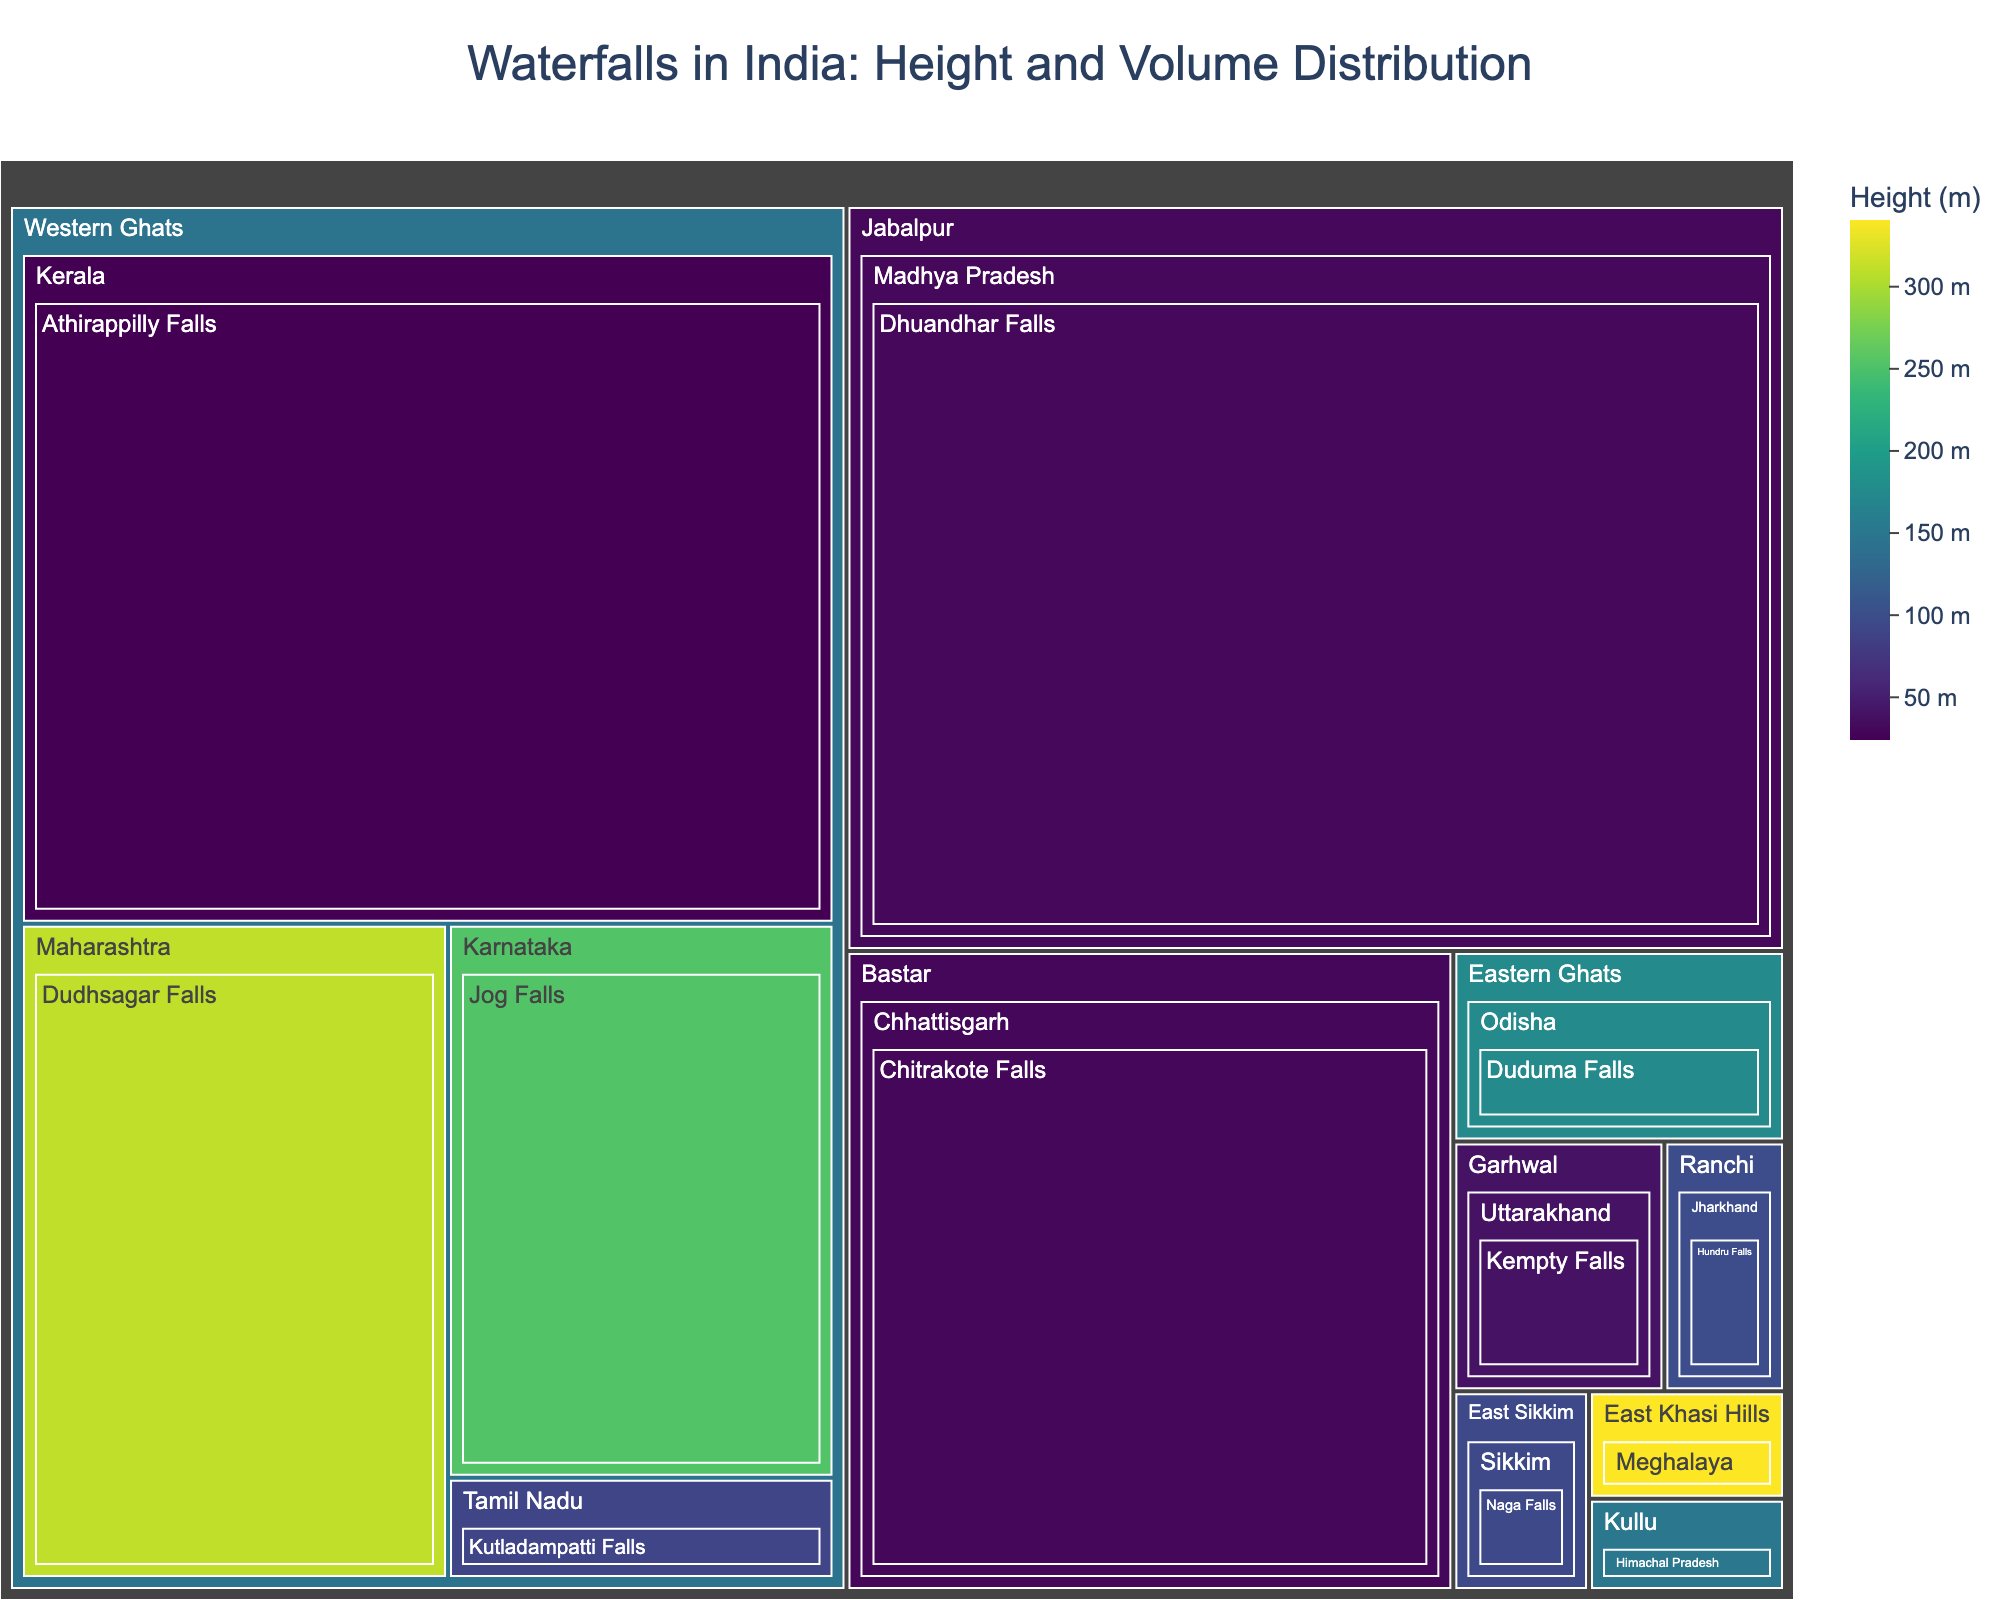What is the height of Nohkalikai Falls? Look for the Nohkalikai Falls in the East Khasi Hills, Meghalaya region in the treemap, and check the height value associated with it.
Answer: 340 meters Which waterfall has the highest water volume? Identify the waterfall with the largest area in the treemap representing volume and verify the numerical value.
Answer: Dhuandhar Falls What is the average height of waterfalls in the Western Ghats region? Identify all waterfalls in the Western Ghats region: Jog Falls, Kutladampatti Falls, Dudhsagar Falls, Athirappilly Falls. Add their heights (253 + 90 + 310 + 24 = 677) and divide by the number of waterfalls (4).
Answer: 169.25 meters Which region contains the highest waterfall? Identify the waterfall with the greatest height in the treemap and note its region.
Answer: East Khasi Hills (Nohkalikai Falls) How many waterfalls are there in the Eastern Ghats region? Locate the Eastern Ghats region on the treemap and count the waterfalls within it.
Answer: 1 Which waterfall in the Western Ghats has the largest water volume? Locate each waterfall in the Western Ghats (Jog Falls, Kutladampatti Falls, Dudhsagar Falls, Athirappilly Falls) and compare their volumes.
Answer: Athirappilly Falls What is the combined water volume of the waterfalls in the Western Ghats region? Identify the water volumes of Jog Falls (153 m³/s), Kutladampatti Falls (28 m³/s), Dudhsagar Falls (200 m³/s), and Athirappilly Falls (390 m³/s). Add them together (153 + 28 + 200 + 390 = 771).
Answer: 771 m³/s How does the height of Jana Falls compare to Kempty Falls? Find Jana Falls in Kullu, Himachal Pradesh (150 meters) and compare its height with Kempty Falls in Garhwal, Uttarakhand (40 meters).
Answer: Jana Falls is taller If you sum the heights of the waterfalls in the Bastar and Jabalpur regions, what is the total? Locate Chitrakote Falls in Bastar (29 meters) and Dhuandhar Falls in Jabalpur (30 meters), then add their heights (29 + 30).
Answer: 59 meters Which waterfall has the shortest height listed in the treemap? Identify the waterfall with the smallest height value in the treemap.
Answer: Athirappilly Falls 